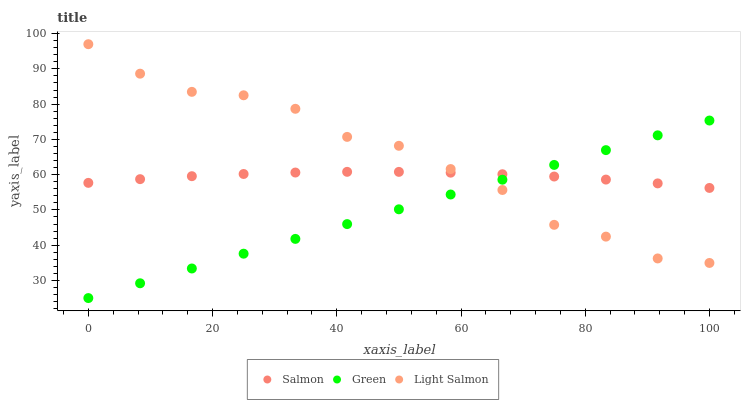Does Green have the minimum area under the curve?
Answer yes or no. Yes. Does Light Salmon have the maximum area under the curve?
Answer yes or no. Yes. Does Salmon have the minimum area under the curve?
Answer yes or no. No. Does Salmon have the maximum area under the curve?
Answer yes or no. No. Is Green the smoothest?
Answer yes or no. Yes. Is Light Salmon the roughest?
Answer yes or no. Yes. Is Salmon the smoothest?
Answer yes or no. No. Is Salmon the roughest?
Answer yes or no. No. Does Green have the lowest value?
Answer yes or no. Yes. Does Light Salmon have the lowest value?
Answer yes or no. No. Does Light Salmon have the highest value?
Answer yes or no. Yes. Does Salmon have the highest value?
Answer yes or no. No. Does Green intersect Light Salmon?
Answer yes or no. Yes. Is Green less than Light Salmon?
Answer yes or no. No. Is Green greater than Light Salmon?
Answer yes or no. No. 